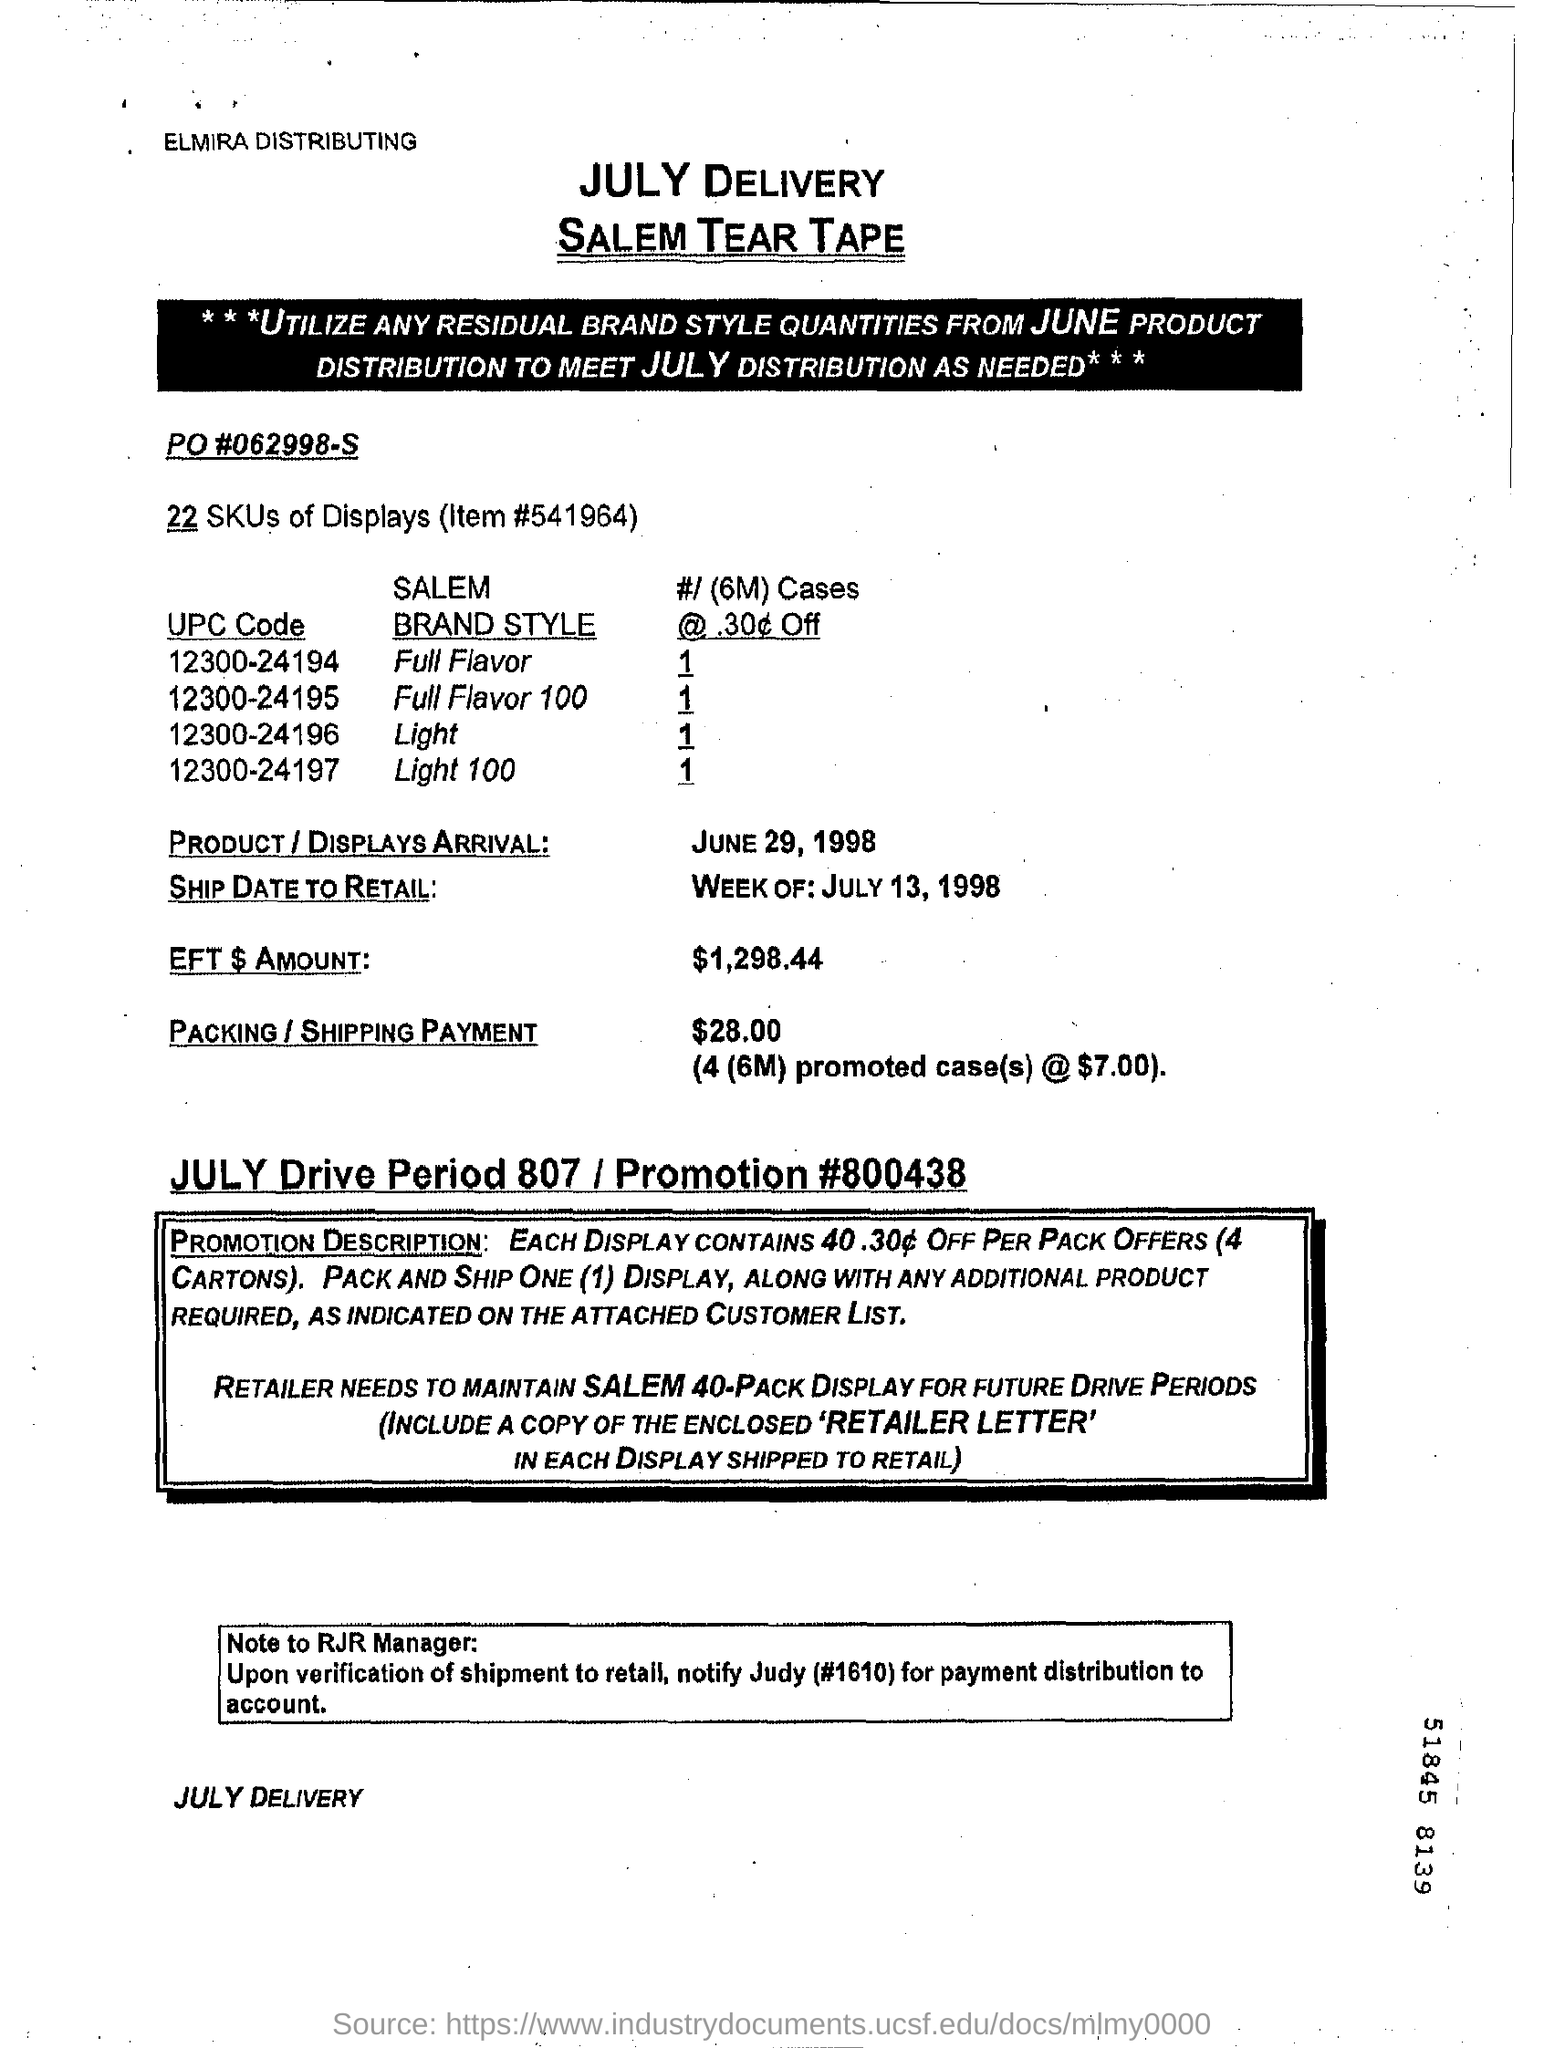Mention a couple of crucial points in this snapshot. The packing and shipping payment is $28.00 and includes 4 (6M) promoted cases at a cost of $7.00 each. The ship date to retail for the week of July 13, 1998 is [insert date]. Please provide the promotion code: 800438... The item number is 541964... The arrival of the product/displays is scheduled for June 29, 1998. 